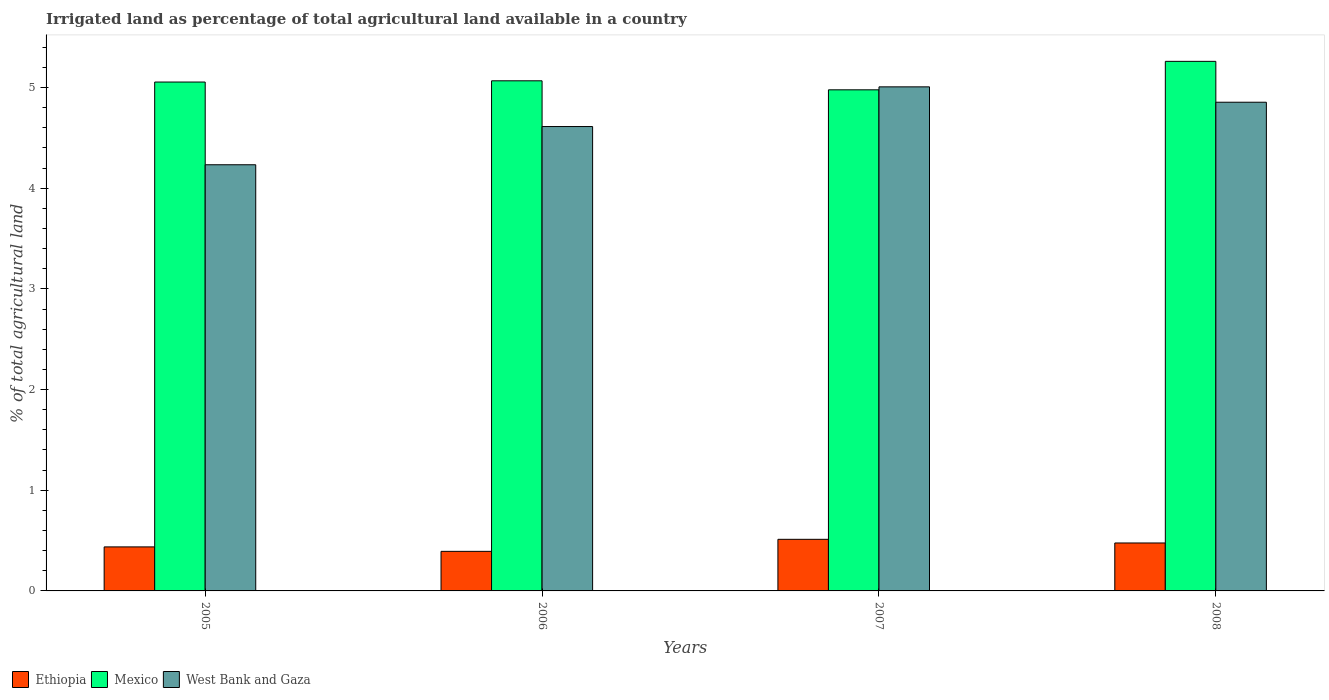Are the number of bars on each tick of the X-axis equal?
Your response must be concise. Yes. What is the label of the 3rd group of bars from the left?
Keep it short and to the point. 2007. What is the percentage of irrigated land in West Bank and Gaza in 2006?
Offer a very short reply. 4.61. Across all years, what is the maximum percentage of irrigated land in Ethiopia?
Offer a very short reply. 0.51. Across all years, what is the minimum percentage of irrigated land in Ethiopia?
Keep it short and to the point. 0.39. In which year was the percentage of irrigated land in West Bank and Gaza maximum?
Ensure brevity in your answer.  2007. In which year was the percentage of irrigated land in Mexico minimum?
Ensure brevity in your answer.  2007. What is the total percentage of irrigated land in Ethiopia in the graph?
Ensure brevity in your answer.  1.82. What is the difference between the percentage of irrigated land in Ethiopia in 2007 and that in 2008?
Give a very brief answer. 0.04. What is the difference between the percentage of irrigated land in Mexico in 2008 and the percentage of irrigated land in West Bank and Gaza in 2005?
Provide a succinct answer. 1.03. What is the average percentage of irrigated land in West Bank and Gaza per year?
Offer a terse response. 4.68. In the year 2008, what is the difference between the percentage of irrigated land in West Bank and Gaza and percentage of irrigated land in Mexico?
Offer a terse response. -0.41. What is the ratio of the percentage of irrigated land in Ethiopia in 2005 to that in 2006?
Offer a very short reply. 1.11. Is the percentage of irrigated land in Ethiopia in 2005 less than that in 2007?
Ensure brevity in your answer.  Yes. What is the difference between the highest and the second highest percentage of irrigated land in Mexico?
Make the answer very short. 0.19. What is the difference between the highest and the lowest percentage of irrigated land in West Bank and Gaza?
Your answer should be very brief. 0.77. Is the sum of the percentage of irrigated land in Mexico in 2005 and 2006 greater than the maximum percentage of irrigated land in West Bank and Gaza across all years?
Provide a succinct answer. Yes. What does the 3rd bar from the left in 2008 represents?
Your answer should be very brief. West Bank and Gaza. What does the 2nd bar from the right in 2005 represents?
Keep it short and to the point. Mexico. Is it the case that in every year, the sum of the percentage of irrigated land in Mexico and percentage of irrigated land in Ethiopia is greater than the percentage of irrigated land in West Bank and Gaza?
Provide a succinct answer. Yes. What is the difference between two consecutive major ticks on the Y-axis?
Offer a very short reply. 1. Does the graph contain grids?
Ensure brevity in your answer.  No. What is the title of the graph?
Your answer should be compact. Irrigated land as percentage of total agricultural land available in a country. Does "Low income" appear as one of the legend labels in the graph?
Your answer should be compact. No. What is the label or title of the X-axis?
Make the answer very short. Years. What is the label or title of the Y-axis?
Provide a short and direct response. % of total agricultural land. What is the % of total agricultural land in Ethiopia in 2005?
Make the answer very short. 0.44. What is the % of total agricultural land in Mexico in 2005?
Ensure brevity in your answer.  5.05. What is the % of total agricultural land of West Bank and Gaza in 2005?
Provide a succinct answer. 4.23. What is the % of total agricultural land of Ethiopia in 2006?
Your answer should be very brief. 0.39. What is the % of total agricultural land of Mexico in 2006?
Your response must be concise. 5.07. What is the % of total agricultural land of West Bank and Gaza in 2006?
Provide a succinct answer. 4.61. What is the % of total agricultural land of Ethiopia in 2007?
Give a very brief answer. 0.51. What is the % of total agricultural land in Mexico in 2007?
Keep it short and to the point. 4.98. What is the % of total agricultural land of West Bank and Gaza in 2007?
Your answer should be compact. 5.01. What is the % of total agricultural land of Ethiopia in 2008?
Your answer should be very brief. 0.48. What is the % of total agricultural land in Mexico in 2008?
Make the answer very short. 5.26. What is the % of total agricultural land of West Bank and Gaza in 2008?
Give a very brief answer. 4.85. Across all years, what is the maximum % of total agricultural land of Ethiopia?
Your response must be concise. 0.51. Across all years, what is the maximum % of total agricultural land in Mexico?
Keep it short and to the point. 5.26. Across all years, what is the maximum % of total agricultural land in West Bank and Gaza?
Provide a short and direct response. 5.01. Across all years, what is the minimum % of total agricultural land of Ethiopia?
Provide a succinct answer. 0.39. Across all years, what is the minimum % of total agricultural land in Mexico?
Provide a short and direct response. 4.98. Across all years, what is the minimum % of total agricultural land of West Bank and Gaza?
Provide a succinct answer. 4.23. What is the total % of total agricultural land of Ethiopia in the graph?
Your answer should be compact. 1.82. What is the total % of total agricultural land of Mexico in the graph?
Make the answer very short. 20.36. What is the total % of total agricultural land in West Bank and Gaza in the graph?
Your response must be concise. 18.71. What is the difference between the % of total agricultural land in Ethiopia in 2005 and that in 2006?
Your answer should be very brief. 0.04. What is the difference between the % of total agricultural land in Mexico in 2005 and that in 2006?
Give a very brief answer. -0.01. What is the difference between the % of total agricultural land of West Bank and Gaza in 2005 and that in 2006?
Offer a very short reply. -0.38. What is the difference between the % of total agricultural land of Ethiopia in 2005 and that in 2007?
Keep it short and to the point. -0.08. What is the difference between the % of total agricultural land in Mexico in 2005 and that in 2007?
Ensure brevity in your answer.  0.08. What is the difference between the % of total agricultural land in West Bank and Gaza in 2005 and that in 2007?
Make the answer very short. -0.77. What is the difference between the % of total agricultural land in Ethiopia in 2005 and that in 2008?
Ensure brevity in your answer.  -0.04. What is the difference between the % of total agricultural land in Mexico in 2005 and that in 2008?
Your answer should be compact. -0.21. What is the difference between the % of total agricultural land of West Bank and Gaza in 2005 and that in 2008?
Make the answer very short. -0.62. What is the difference between the % of total agricultural land of Ethiopia in 2006 and that in 2007?
Make the answer very short. -0.12. What is the difference between the % of total agricultural land in Mexico in 2006 and that in 2007?
Provide a succinct answer. 0.09. What is the difference between the % of total agricultural land of West Bank and Gaza in 2006 and that in 2007?
Your answer should be compact. -0.39. What is the difference between the % of total agricultural land in Ethiopia in 2006 and that in 2008?
Your response must be concise. -0.08. What is the difference between the % of total agricultural land of Mexico in 2006 and that in 2008?
Your response must be concise. -0.19. What is the difference between the % of total agricultural land in West Bank and Gaza in 2006 and that in 2008?
Ensure brevity in your answer.  -0.24. What is the difference between the % of total agricultural land of Ethiopia in 2007 and that in 2008?
Offer a terse response. 0.04. What is the difference between the % of total agricultural land in Mexico in 2007 and that in 2008?
Keep it short and to the point. -0.28. What is the difference between the % of total agricultural land of West Bank and Gaza in 2007 and that in 2008?
Provide a succinct answer. 0.15. What is the difference between the % of total agricultural land in Ethiopia in 2005 and the % of total agricultural land in Mexico in 2006?
Your response must be concise. -4.63. What is the difference between the % of total agricultural land in Ethiopia in 2005 and the % of total agricultural land in West Bank and Gaza in 2006?
Give a very brief answer. -4.18. What is the difference between the % of total agricultural land of Mexico in 2005 and the % of total agricultural land of West Bank and Gaza in 2006?
Give a very brief answer. 0.44. What is the difference between the % of total agricultural land in Ethiopia in 2005 and the % of total agricultural land in Mexico in 2007?
Give a very brief answer. -4.54. What is the difference between the % of total agricultural land in Ethiopia in 2005 and the % of total agricultural land in West Bank and Gaza in 2007?
Give a very brief answer. -4.57. What is the difference between the % of total agricultural land in Mexico in 2005 and the % of total agricultural land in West Bank and Gaza in 2007?
Make the answer very short. 0.05. What is the difference between the % of total agricultural land of Ethiopia in 2005 and the % of total agricultural land of Mexico in 2008?
Offer a terse response. -4.82. What is the difference between the % of total agricultural land of Ethiopia in 2005 and the % of total agricultural land of West Bank and Gaza in 2008?
Your answer should be very brief. -4.42. What is the difference between the % of total agricultural land of Mexico in 2005 and the % of total agricultural land of West Bank and Gaza in 2008?
Provide a short and direct response. 0.2. What is the difference between the % of total agricultural land of Ethiopia in 2006 and the % of total agricultural land of Mexico in 2007?
Your response must be concise. -4.58. What is the difference between the % of total agricultural land in Ethiopia in 2006 and the % of total agricultural land in West Bank and Gaza in 2007?
Your answer should be compact. -4.61. What is the difference between the % of total agricultural land in Ethiopia in 2006 and the % of total agricultural land in Mexico in 2008?
Provide a succinct answer. -4.87. What is the difference between the % of total agricultural land in Ethiopia in 2006 and the % of total agricultural land in West Bank and Gaza in 2008?
Give a very brief answer. -4.46. What is the difference between the % of total agricultural land in Mexico in 2006 and the % of total agricultural land in West Bank and Gaza in 2008?
Provide a succinct answer. 0.21. What is the difference between the % of total agricultural land in Ethiopia in 2007 and the % of total agricultural land in Mexico in 2008?
Ensure brevity in your answer.  -4.75. What is the difference between the % of total agricultural land in Ethiopia in 2007 and the % of total agricultural land in West Bank and Gaza in 2008?
Keep it short and to the point. -4.34. What is the difference between the % of total agricultural land of Mexico in 2007 and the % of total agricultural land of West Bank and Gaza in 2008?
Provide a short and direct response. 0.12. What is the average % of total agricultural land in Ethiopia per year?
Offer a very short reply. 0.45. What is the average % of total agricultural land of Mexico per year?
Provide a short and direct response. 5.09. What is the average % of total agricultural land of West Bank and Gaza per year?
Give a very brief answer. 4.68. In the year 2005, what is the difference between the % of total agricultural land of Ethiopia and % of total agricultural land of Mexico?
Provide a succinct answer. -4.62. In the year 2005, what is the difference between the % of total agricultural land of Ethiopia and % of total agricultural land of West Bank and Gaza?
Offer a very short reply. -3.8. In the year 2005, what is the difference between the % of total agricultural land in Mexico and % of total agricultural land in West Bank and Gaza?
Your response must be concise. 0.82. In the year 2006, what is the difference between the % of total agricultural land in Ethiopia and % of total agricultural land in Mexico?
Keep it short and to the point. -4.67. In the year 2006, what is the difference between the % of total agricultural land of Ethiopia and % of total agricultural land of West Bank and Gaza?
Offer a terse response. -4.22. In the year 2006, what is the difference between the % of total agricultural land in Mexico and % of total agricultural land in West Bank and Gaza?
Ensure brevity in your answer.  0.45. In the year 2007, what is the difference between the % of total agricultural land of Ethiopia and % of total agricultural land of Mexico?
Provide a short and direct response. -4.46. In the year 2007, what is the difference between the % of total agricultural land of Ethiopia and % of total agricultural land of West Bank and Gaza?
Your answer should be compact. -4.49. In the year 2007, what is the difference between the % of total agricultural land of Mexico and % of total agricultural land of West Bank and Gaza?
Offer a very short reply. -0.03. In the year 2008, what is the difference between the % of total agricultural land in Ethiopia and % of total agricultural land in Mexico?
Your answer should be very brief. -4.78. In the year 2008, what is the difference between the % of total agricultural land in Ethiopia and % of total agricultural land in West Bank and Gaza?
Your answer should be compact. -4.38. In the year 2008, what is the difference between the % of total agricultural land in Mexico and % of total agricultural land in West Bank and Gaza?
Your answer should be very brief. 0.41. What is the ratio of the % of total agricultural land in Ethiopia in 2005 to that in 2006?
Your answer should be compact. 1.11. What is the ratio of the % of total agricultural land in West Bank and Gaza in 2005 to that in 2006?
Your response must be concise. 0.92. What is the ratio of the % of total agricultural land of Ethiopia in 2005 to that in 2007?
Keep it short and to the point. 0.85. What is the ratio of the % of total agricultural land in Mexico in 2005 to that in 2007?
Provide a short and direct response. 1.02. What is the ratio of the % of total agricultural land in West Bank and Gaza in 2005 to that in 2007?
Ensure brevity in your answer.  0.85. What is the ratio of the % of total agricultural land of Ethiopia in 2005 to that in 2008?
Make the answer very short. 0.92. What is the ratio of the % of total agricultural land of Mexico in 2005 to that in 2008?
Provide a succinct answer. 0.96. What is the ratio of the % of total agricultural land in West Bank and Gaza in 2005 to that in 2008?
Offer a terse response. 0.87. What is the ratio of the % of total agricultural land in Ethiopia in 2006 to that in 2007?
Ensure brevity in your answer.  0.77. What is the ratio of the % of total agricultural land in West Bank and Gaza in 2006 to that in 2007?
Offer a very short reply. 0.92. What is the ratio of the % of total agricultural land in Ethiopia in 2006 to that in 2008?
Offer a very short reply. 0.83. What is the ratio of the % of total agricultural land in Mexico in 2006 to that in 2008?
Offer a terse response. 0.96. What is the ratio of the % of total agricultural land in West Bank and Gaza in 2006 to that in 2008?
Offer a terse response. 0.95. What is the ratio of the % of total agricultural land of Ethiopia in 2007 to that in 2008?
Your answer should be very brief. 1.08. What is the ratio of the % of total agricultural land of Mexico in 2007 to that in 2008?
Offer a very short reply. 0.95. What is the ratio of the % of total agricultural land in West Bank and Gaza in 2007 to that in 2008?
Ensure brevity in your answer.  1.03. What is the difference between the highest and the second highest % of total agricultural land in Ethiopia?
Your response must be concise. 0.04. What is the difference between the highest and the second highest % of total agricultural land of Mexico?
Keep it short and to the point. 0.19. What is the difference between the highest and the second highest % of total agricultural land of West Bank and Gaza?
Your answer should be very brief. 0.15. What is the difference between the highest and the lowest % of total agricultural land in Ethiopia?
Offer a very short reply. 0.12. What is the difference between the highest and the lowest % of total agricultural land in Mexico?
Offer a very short reply. 0.28. What is the difference between the highest and the lowest % of total agricultural land of West Bank and Gaza?
Your answer should be compact. 0.77. 